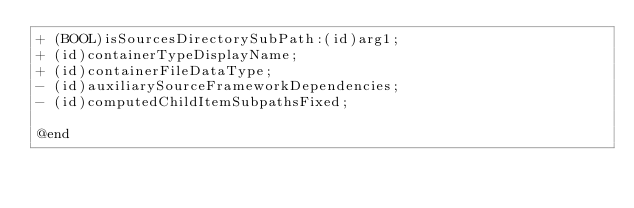Convert code to text. <code><loc_0><loc_0><loc_500><loc_500><_C_>+ (BOOL)isSourcesDirectorySubPath:(id)arg1;
+ (id)containerTypeDisplayName;
+ (id)containerFileDataType;
- (id)auxiliarySourceFrameworkDependencies;
- (id)computedChildItemSubpathsFixed;

@end

</code> 